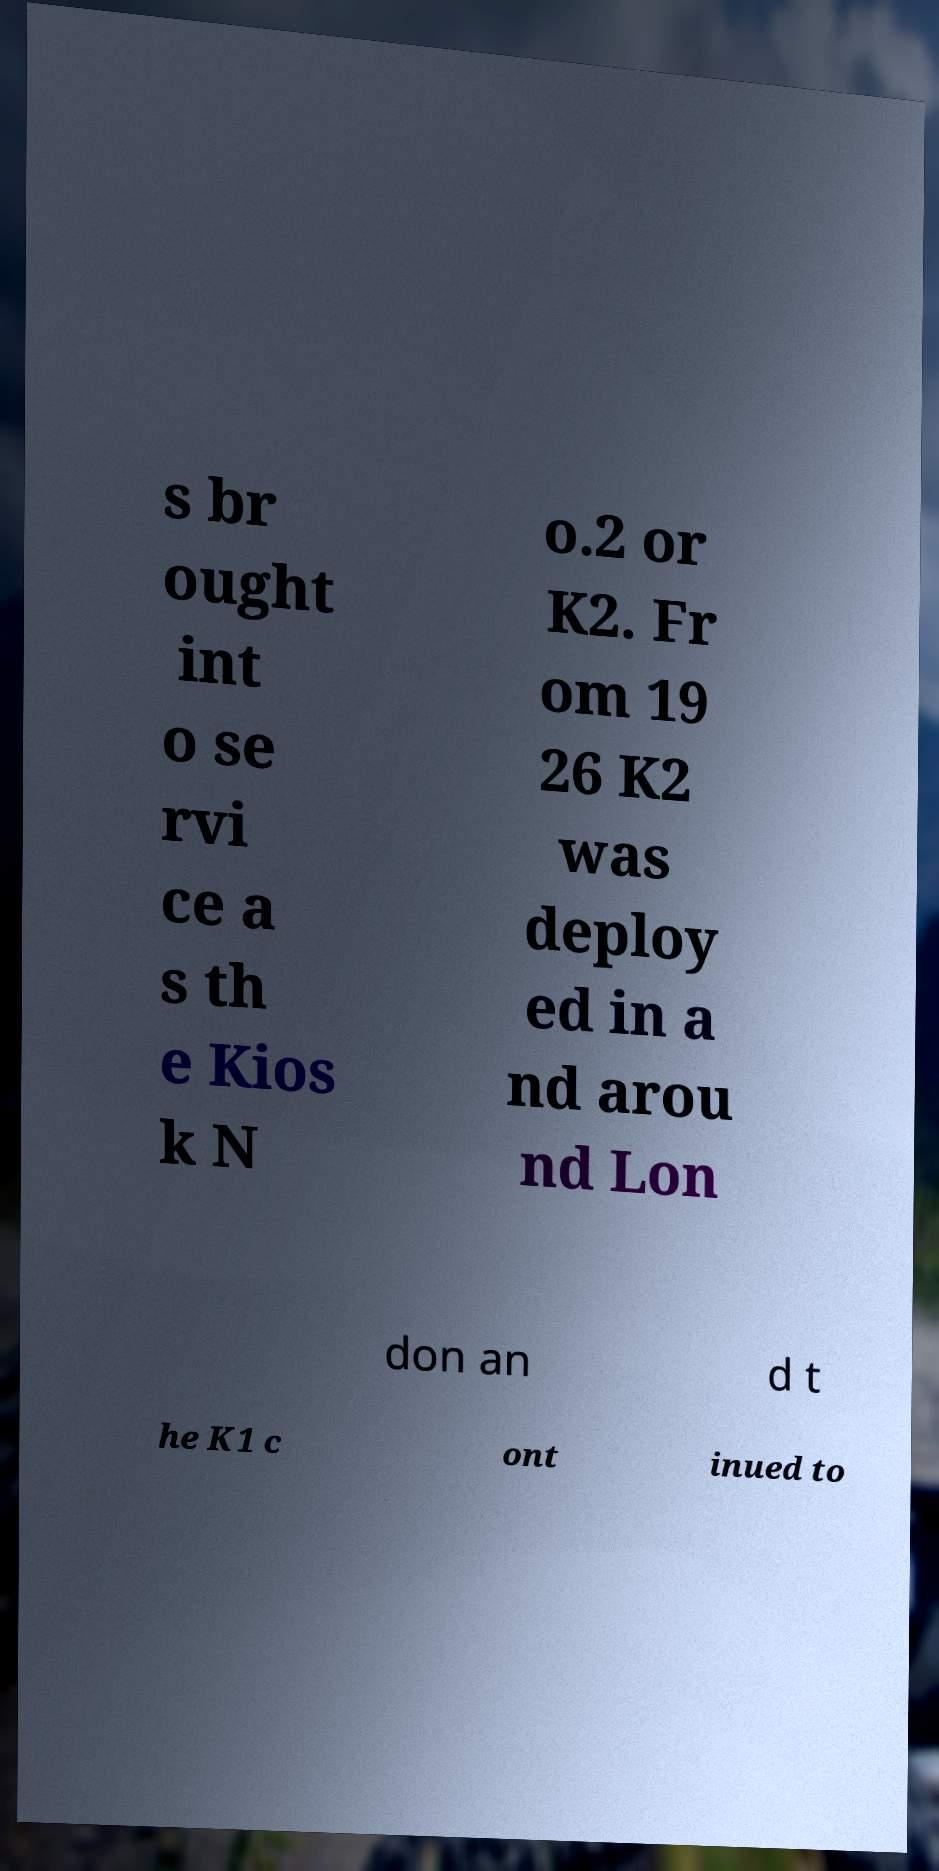There's text embedded in this image that I need extracted. Can you transcribe it verbatim? s br ought int o se rvi ce a s th e Kios k N o.2 or K2. Fr om 19 26 K2 was deploy ed in a nd arou nd Lon don an d t he K1 c ont inued to 